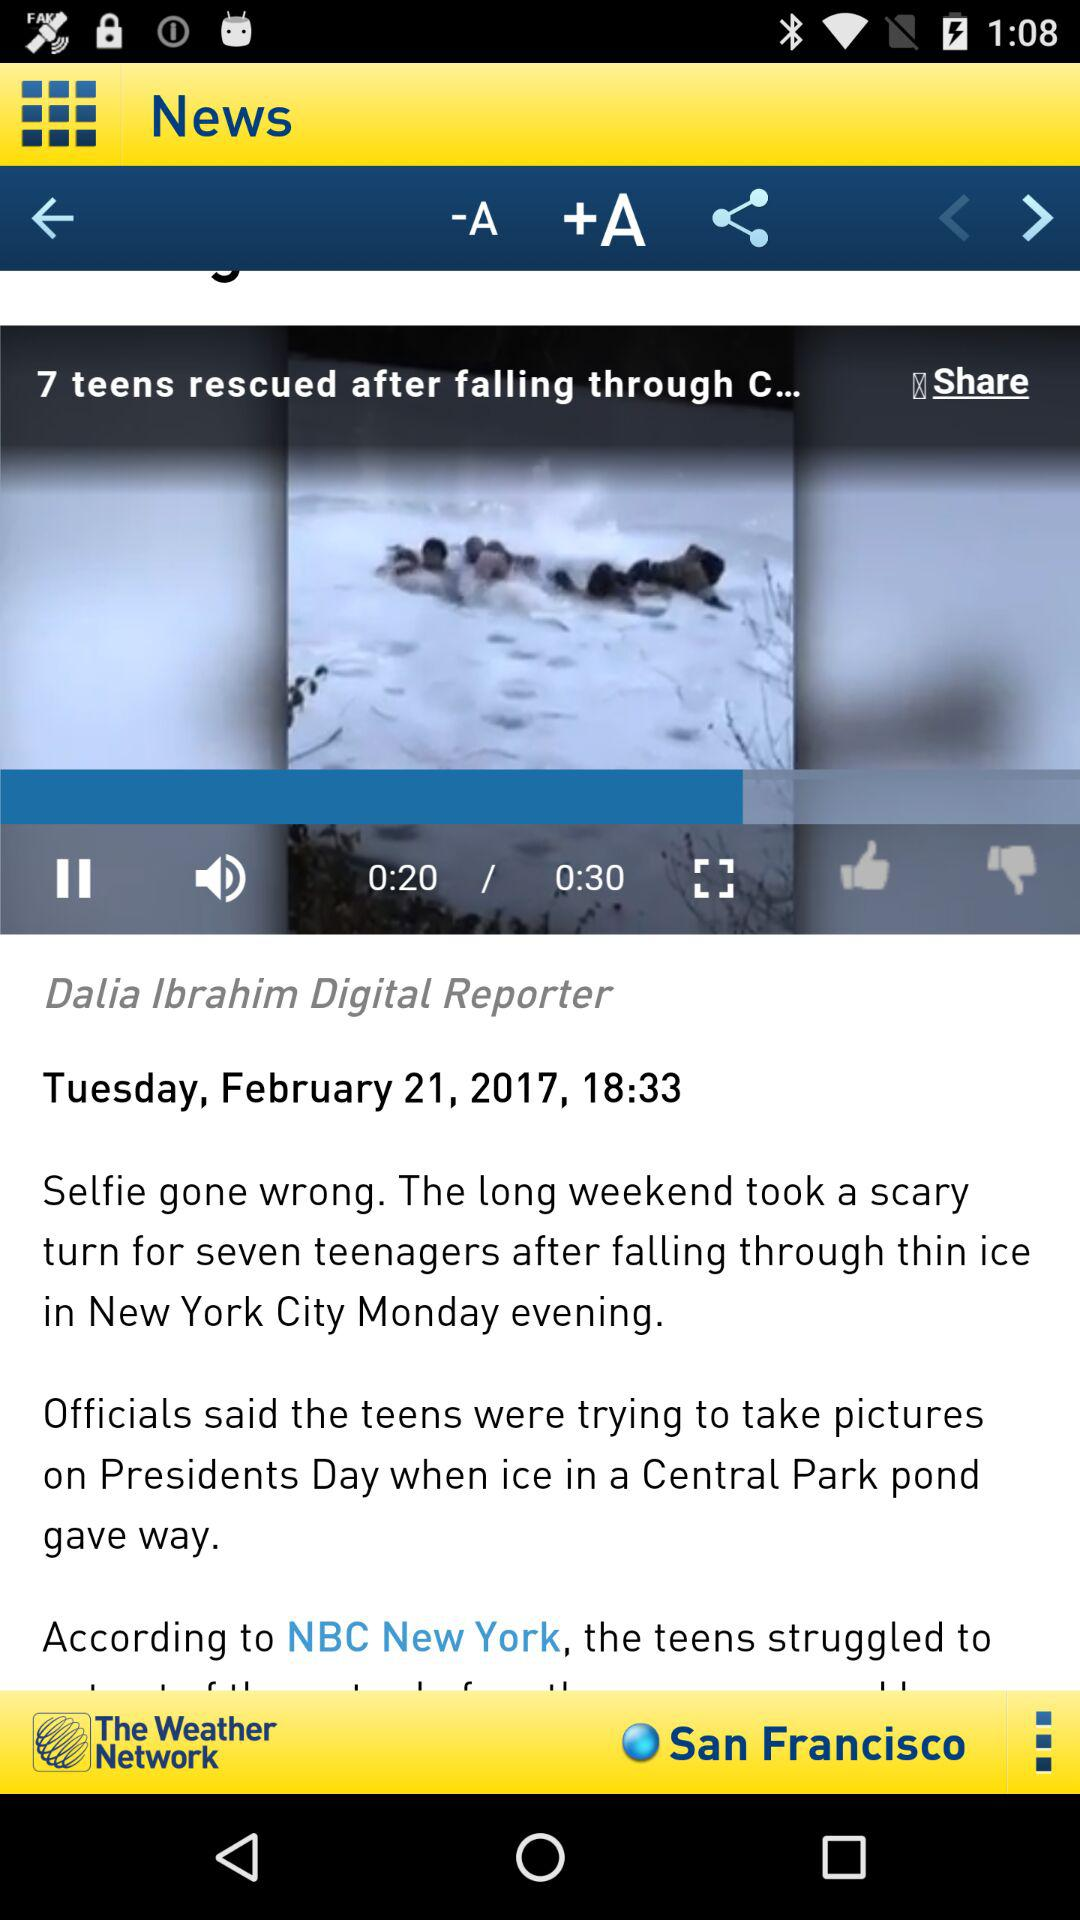When was the article published? The article was published on Tuesday, February 21, 2017 at 18:33. 